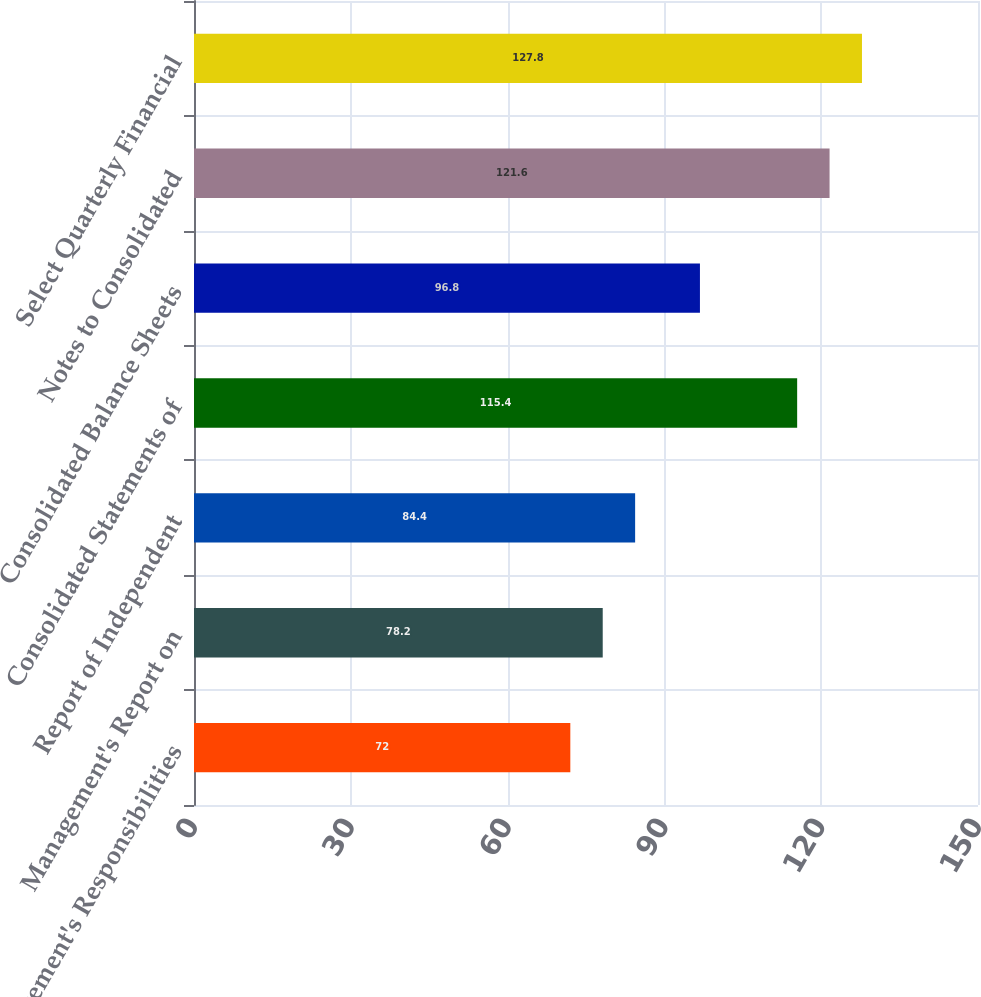Convert chart. <chart><loc_0><loc_0><loc_500><loc_500><bar_chart><fcel>Management's Responsibilities<fcel>Management's Report on<fcel>Report of Independent<fcel>Consolidated Statements of<fcel>Consolidated Balance Sheets<fcel>Notes to Consolidated<fcel>Select Quarterly Financial<nl><fcel>72<fcel>78.2<fcel>84.4<fcel>115.4<fcel>96.8<fcel>121.6<fcel>127.8<nl></chart> 